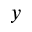<formula> <loc_0><loc_0><loc_500><loc_500>_ { y }</formula> 